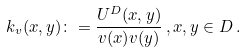<formula> <loc_0><loc_0><loc_500><loc_500>k _ { v } ( x , y ) \colon = \frac { U ^ { D } ( x , y ) } { v ( x ) v ( y ) } \, , x , y \in D \, .</formula> 